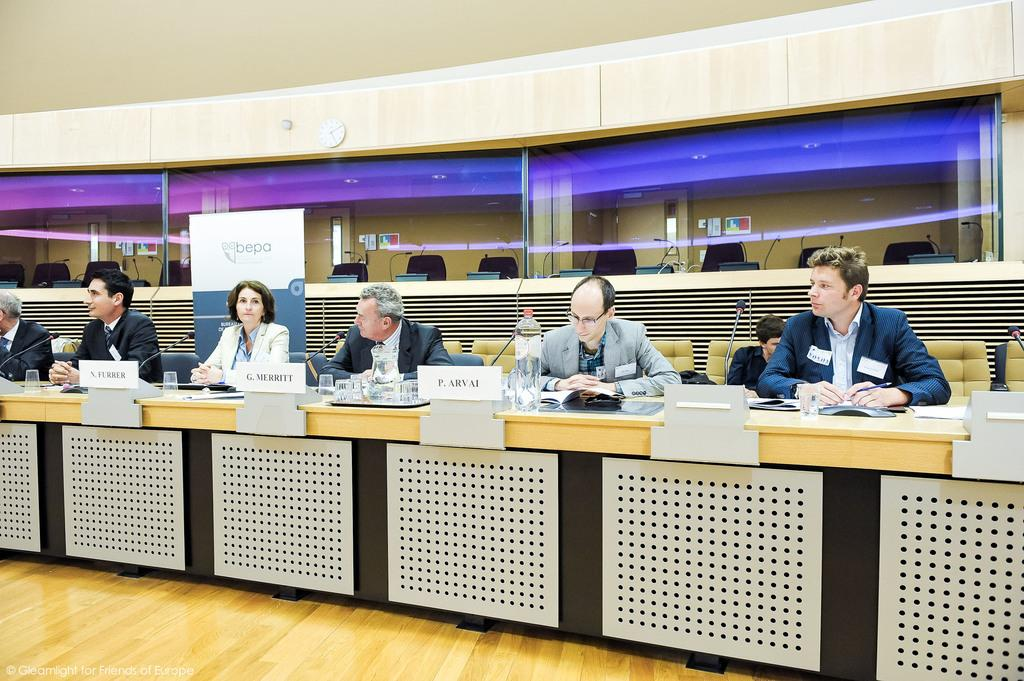What are the people in the image doing? The people in the image are sitting on chairs. What objects are on the tray in the image? There are glasses on a tray in the image. What device is used for amplifying sound in the image? There is a microphone on a stand in the image. What is placed on the ground in the image? There is a banner on the ground in the image. What type of lettuce is being used as a decoration on the microphone stand in the image? There is no lettuce present in the image, and the microphone stand is not being used as a decoration. 